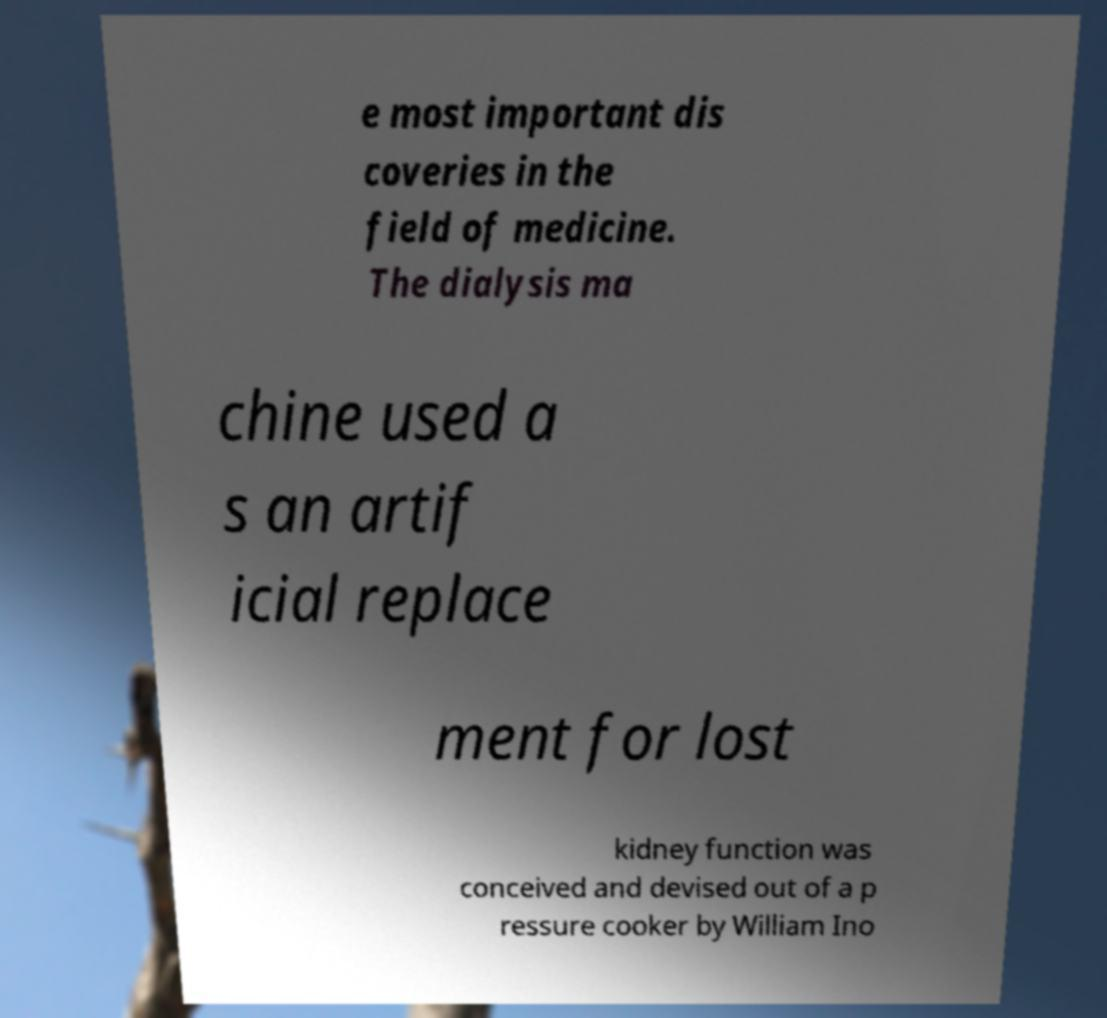Could you extract and type out the text from this image? e most important dis coveries in the field of medicine. The dialysis ma chine used a s an artif icial replace ment for lost kidney function was conceived and devised out of a p ressure cooker by William Ino 